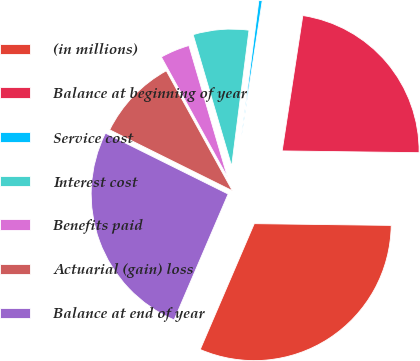Convert chart. <chart><loc_0><loc_0><loc_500><loc_500><pie_chart><fcel>(in millions)<fcel>Balance at beginning of year<fcel>Service cost<fcel>Interest cost<fcel>Benefits paid<fcel>Actuarial (gain) loss<fcel>Balance at end of year<nl><fcel>31.25%<fcel>22.79%<fcel>0.39%<fcel>6.56%<fcel>3.48%<fcel>9.65%<fcel>25.88%<nl></chart> 